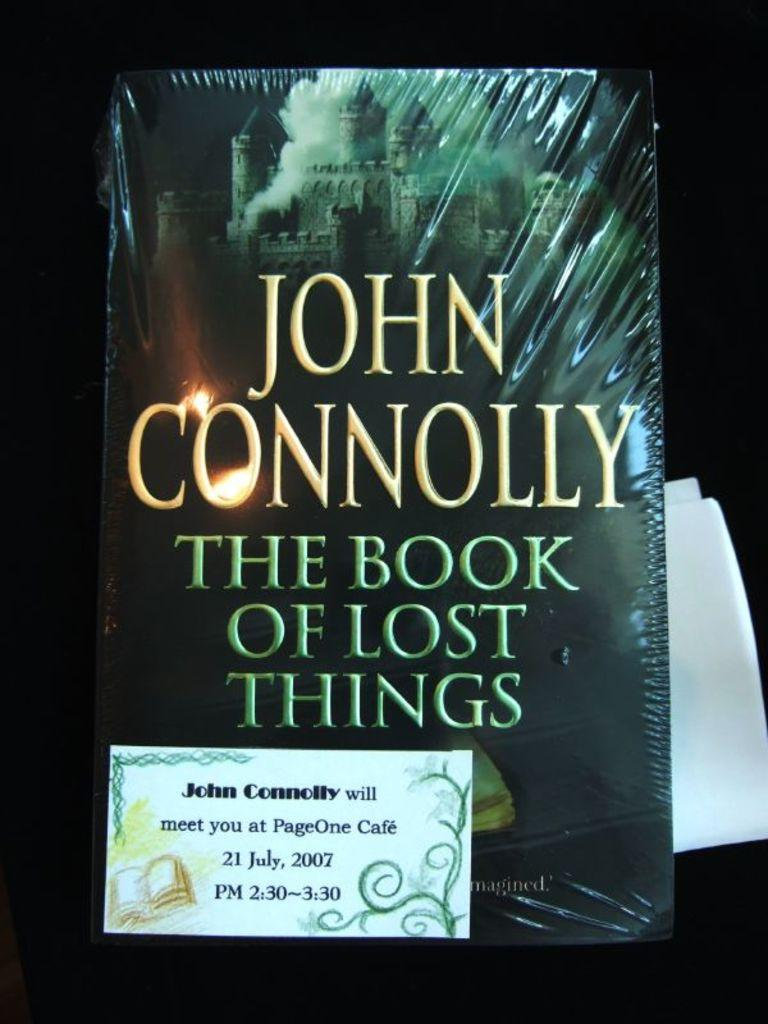What is present in the image that suggests the person is engaged in an activity? There is a book in the image with something written on it, which suggests the person is reading or writing. What other items can be seen in the image related to the activity? There is a card and paper in the image, which could also be used for writing or note-taking. What type of grass is growing on the person's head in the image? There is no grass present in the image, nor is there any indication that the person has grass growing on their head. 